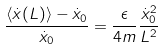Convert formula to latex. <formula><loc_0><loc_0><loc_500><loc_500>\frac { \langle \dot { x } ( L ) \rangle - \dot { x } _ { 0 } } { \dot { x } _ { 0 } } = \frac { \epsilon } { 4 m } \frac { \dot { x } _ { 0 } ^ { 2 } } { L ^ { 2 } }</formula> 